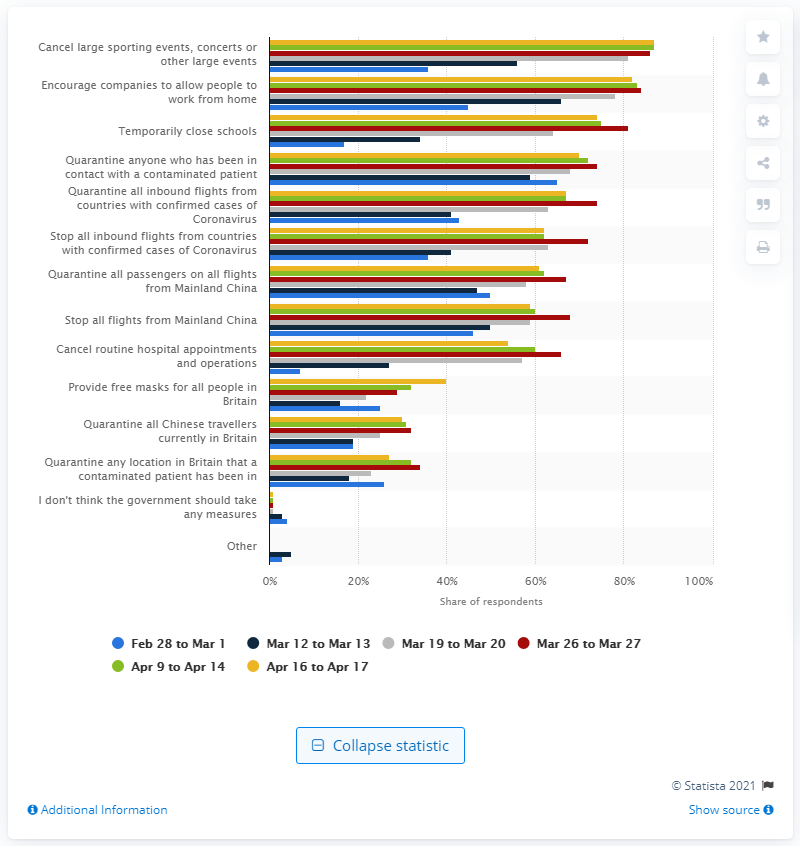Specify some key components in this picture. A recent survey found that 45% of Brits believe that the government should encourage companies to allow their employees to work from home. 